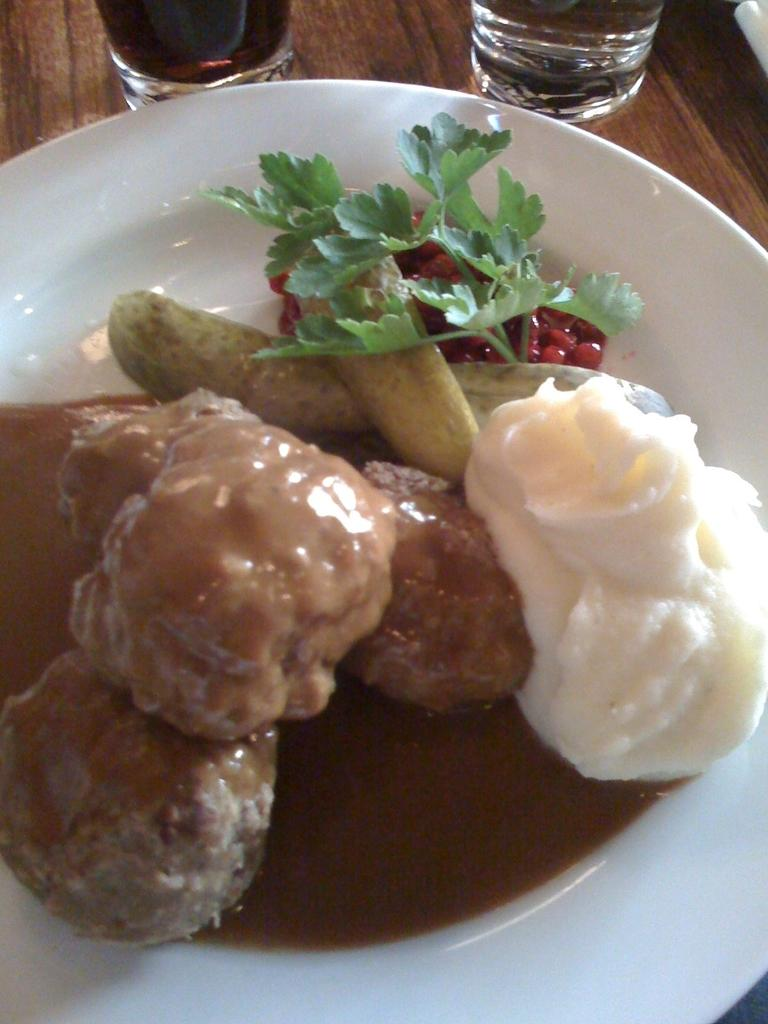What is on the plate that is visible in the image? There is a food item on the plate in the image. How many glasses can be seen in the image? There are two glasses in the image. Where are the plate and glasses located in the image? The plate and glasses are placed on a table in the image. How long does it take for the icicle to form on the plate in the image? There is no icicle present in the image, so it is not possible to determine how long it would take to form. 